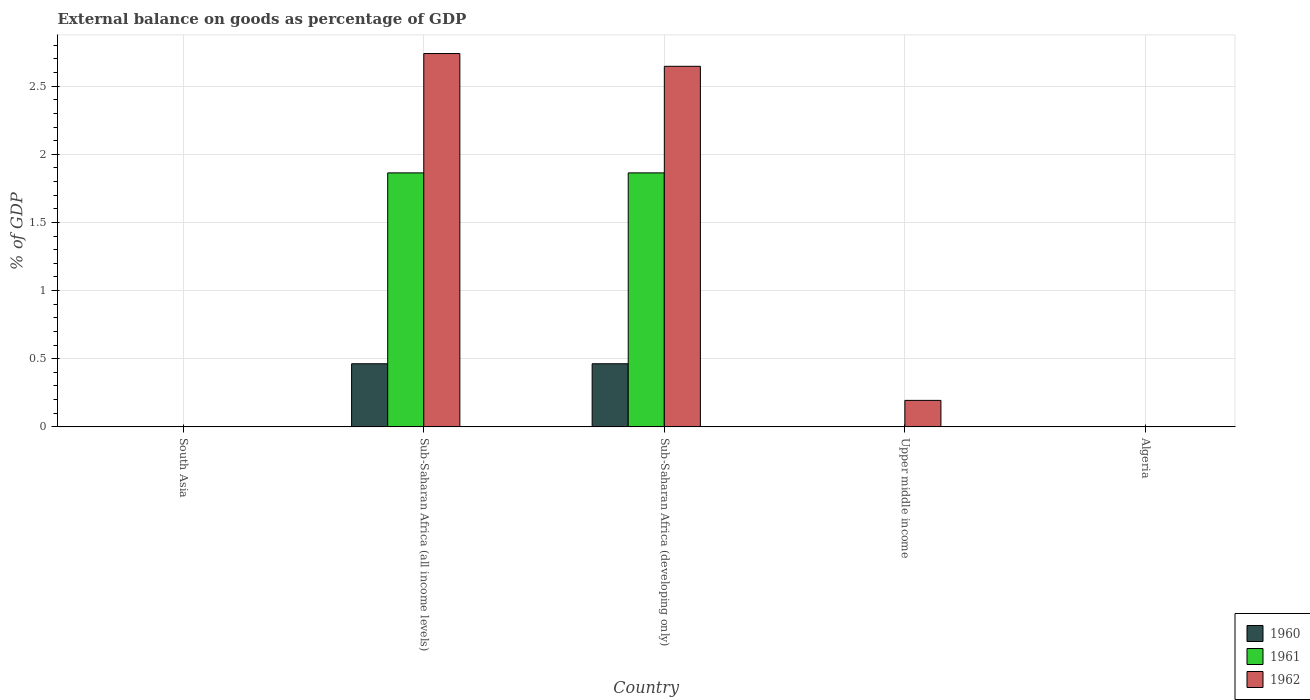Are the number of bars per tick equal to the number of legend labels?
Offer a terse response. No. How many bars are there on the 2nd tick from the left?
Make the answer very short. 3. How many bars are there on the 3rd tick from the right?
Provide a succinct answer. 3. What is the label of the 2nd group of bars from the left?
Make the answer very short. Sub-Saharan Africa (all income levels). What is the external balance on goods as percentage of GDP in 1961 in Sub-Saharan Africa (developing only)?
Offer a very short reply. 1.86. Across all countries, what is the maximum external balance on goods as percentage of GDP in 1960?
Offer a very short reply. 0.46. Across all countries, what is the minimum external balance on goods as percentage of GDP in 1960?
Your answer should be compact. 0. In which country was the external balance on goods as percentage of GDP in 1960 maximum?
Offer a very short reply. Sub-Saharan Africa (developing only). What is the total external balance on goods as percentage of GDP in 1962 in the graph?
Keep it short and to the point. 5.58. What is the difference between the external balance on goods as percentage of GDP in 1960 in Sub-Saharan Africa (all income levels) and that in Sub-Saharan Africa (developing only)?
Give a very brief answer. -1.0935696792557792e-14. What is the difference between the external balance on goods as percentage of GDP in 1960 in Sub-Saharan Africa (all income levels) and the external balance on goods as percentage of GDP in 1962 in Sub-Saharan Africa (developing only)?
Offer a terse response. -2.18. What is the average external balance on goods as percentage of GDP in 1960 per country?
Offer a terse response. 0.19. What is the difference between the external balance on goods as percentage of GDP of/in 1960 and external balance on goods as percentage of GDP of/in 1961 in Sub-Saharan Africa (all income levels)?
Your answer should be very brief. -1.4. In how many countries, is the external balance on goods as percentage of GDP in 1962 greater than 0.7 %?
Provide a short and direct response. 2. What is the difference between the highest and the second highest external balance on goods as percentage of GDP in 1962?
Ensure brevity in your answer.  -2.55. What is the difference between the highest and the lowest external balance on goods as percentage of GDP in 1962?
Your answer should be compact. 2.74. In how many countries, is the external balance on goods as percentage of GDP in 1962 greater than the average external balance on goods as percentage of GDP in 1962 taken over all countries?
Offer a very short reply. 2. Is the sum of the external balance on goods as percentage of GDP in 1962 in Sub-Saharan Africa (all income levels) and Sub-Saharan Africa (developing only) greater than the maximum external balance on goods as percentage of GDP in 1960 across all countries?
Give a very brief answer. Yes. How many countries are there in the graph?
Your response must be concise. 5. What is the difference between two consecutive major ticks on the Y-axis?
Provide a short and direct response. 0.5. Does the graph contain any zero values?
Ensure brevity in your answer.  Yes. Does the graph contain grids?
Offer a very short reply. Yes. Where does the legend appear in the graph?
Keep it short and to the point. Bottom right. How many legend labels are there?
Your answer should be compact. 3. What is the title of the graph?
Ensure brevity in your answer.  External balance on goods as percentage of GDP. Does "1999" appear as one of the legend labels in the graph?
Your answer should be compact. No. What is the label or title of the Y-axis?
Your answer should be very brief. % of GDP. What is the % of GDP in 1960 in South Asia?
Ensure brevity in your answer.  0. What is the % of GDP in 1961 in South Asia?
Offer a very short reply. 0. What is the % of GDP in 1960 in Sub-Saharan Africa (all income levels)?
Provide a succinct answer. 0.46. What is the % of GDP in 1961 in Sub-Saharan Africa (all income levels)?
Your answer should be very brief. 1.86. What is the % of GDP of 1962 in Sub-Saharan Africa (all income levels)?
Your answer should be very brief. 2.74. What is the % of GDP in 1960 in Sub-Saharan Africa (developing only)?
Offer a terse response. 0.46. What is the % of GDP of 1961 in Sub-Saharan Africa (developing only)?
Your response must be concise. 1.86. What is the % of GDP of 1962 in Sub-Saharan Africa (developing only)?
Ensure brevity in your answer.  2.65. What is the % of GDP of 1960 in Upper middle income?
Make the answer very short. 0. What is the % of GDP of 1962 in Upper middle income?
Give a very brief answer. 0.19. What is the % of GDP in 1960 in Algeria?
Ensure brevity in your answer.  0. What is the % of GDP in 1961 in Algeria?
Give a very brief answer. 0. What is the % of GDP in 1962 in Algeria?
Offer a very short reply. 0. Across all countries, what is the maximum % of GDP in 1960?
Ensure brevity in your answer.  0.46. Across all countries, what is the maximum % of GDP in 1961?
Make the answer very short. 1.86. Across all countries, what is the maximum % of GDP in 1962?
Keep it short and to the point. 2.74. What is the total % of GDP of 1960 in the graph?
Keep it short and to the point. 0.93. What is the total % of GDP in 1961 in the graph?
Give a very brief answer. 3.73. What is the total % of GDP in 1962 in the graph?
Provide a succinct answer. 5.58. What is the difference between the % of GDP in 1960 in Sub-Saharan Africa (all income levels) and that in Sub-Saharan Africa (developing only)?
Offer a terse response. -0. What is the difference between the % of GDP of 1962 in Sub-Saharan Africa (all income levels) and that in Sub-Saharan Africa (developing only)?
Make the answer very short. 0.09. What is the difference between the % of GDP of 1962 in Sub-Saharan Africa (all income levels) and that in Upper middle income?
Keep it short and to the point. 2.55. What is the difference between the % of GDP in 1962 in Sub-Saharan Africa (developing only) and that in Upper middle income?
Make the answer very short. 2.45. What is the difference between the % of GDP in 1960 in Sub-Saharan Africa (all income levels) and the % of GDP in 1961 in Sub-Saharan Africa (developing only)?
Your answer should be compact. -1.4. What is the difference between the % of GDP of 1960 in Sub-Saharan Africa (all income levels) and the % of GDP of 1962 in Sub-Saharan Africa (developing only)?
Make the answer very short. -2.18. What is the difference between the % of GDP of 1961 in Sub-Saharan Africa (all income levels) and the % of GDP of 1962 in Sub-Saharan Africa (developing only)?
Provide a succinct answer. -0.78. What is the difference between the % of GDP in 1960 in Sub-Saharan Africa (all income levels) and the % of GDP in 1962 in Upper middle income?
Provide a succinct answer. 0.27. What is the difference between the % of GDP in 1961 in Sub-Saharan Africa (all income levels) and the % of GDP in 1962 in Upper middle income?
Ensure brevity in your answer.  1.67. What is the difference between the % of GDP of 1960 in Sub-Saharan Africa (developing only) and the % of GDP of 1962 in Upper middle income?
Your answer should be very brief. 0.27. What is the difference between the % of GDP in 1961 in Sub-Saharan Africa (developing only) and the % of GDP in 1962 in Upper middle income?
Offer a very short reply. 1.67. What is the average % of GDP in 1960 per country?
Your answer should be very brief. 0.19. What is the average % of GDP of 1961 per country?
Keep it short and to the point. 0.75. What is the average % of GDP in 1962 per country?
Provide a succinct answer. 1.12. What is the difference between the % of GDP of 1960 and % of GDP of 1961 in Sub-Saharan Africa (all income levels)?
Ensure brevity in your answer.  -1.4. What is the difference between the % of GDP in 1960 and % of GDP in 1962 in Sub-Saharan Africa (all income levels)?
Your response must be concise. -2.28. What is the difference between the % of GDP in 1961 and % of GDP in 1962 in Sub-Saharan Africa (all income levels)?
Make the answer very short. -0.88. What is the difference between the % of GDP in 1960 and % of GDP in 1961 in Sub-Saharan Africa (developing only)?
Offer a terse response. -1.4. What is the difference between the % of GDP in 1960 and % of GDP in 1962 in Sub-Saharan Africa (developing only)?
Provide a succinct answer. -2.18. What is the difference between the % of GDP in 1961 and % of GDP in 1962 in Sub-Saharan Africa (developing only)?
Make the answer very short. -0.78. What is the ratio of the % of GDP of 1960 in Sub-Saharan Africa (all income levels) to that in Sub-Saharan Africa (developing only)?
Offer a very short reply. 1. What is the ratio of the % of GDP in 1962 in Sub-Saharan Africa (all income levels) to that in Sub-Saharan Africa (developing only)?
Offer a terse response. 1.04. What is the ratio of the % of GDP in 1962 in Sub-Saharan Africa (all income levels) to that in Upper middle income?
Provide a short and direct response. 14.1. What is the ratio of the % of GDP of 1962 in Sub-Saharan Africa (developing only) to that in Upper middle income?
Your response must be concise. 13.62. What is the difference between the highest and the second highest % of GDP of 1962?
Keep it short and to the point. 0.09. What is the difference between the highest and the lowest % of GDP of 1960?
Your answer should be very brief. 0.46. What is the difference between the highest and the lowest % of GDP in 1961?
Provide a succinct answer. 1.86. What is the difference between the highest and the lowest % of GDP in 1962?
Offer a very short reply. 2.74. 